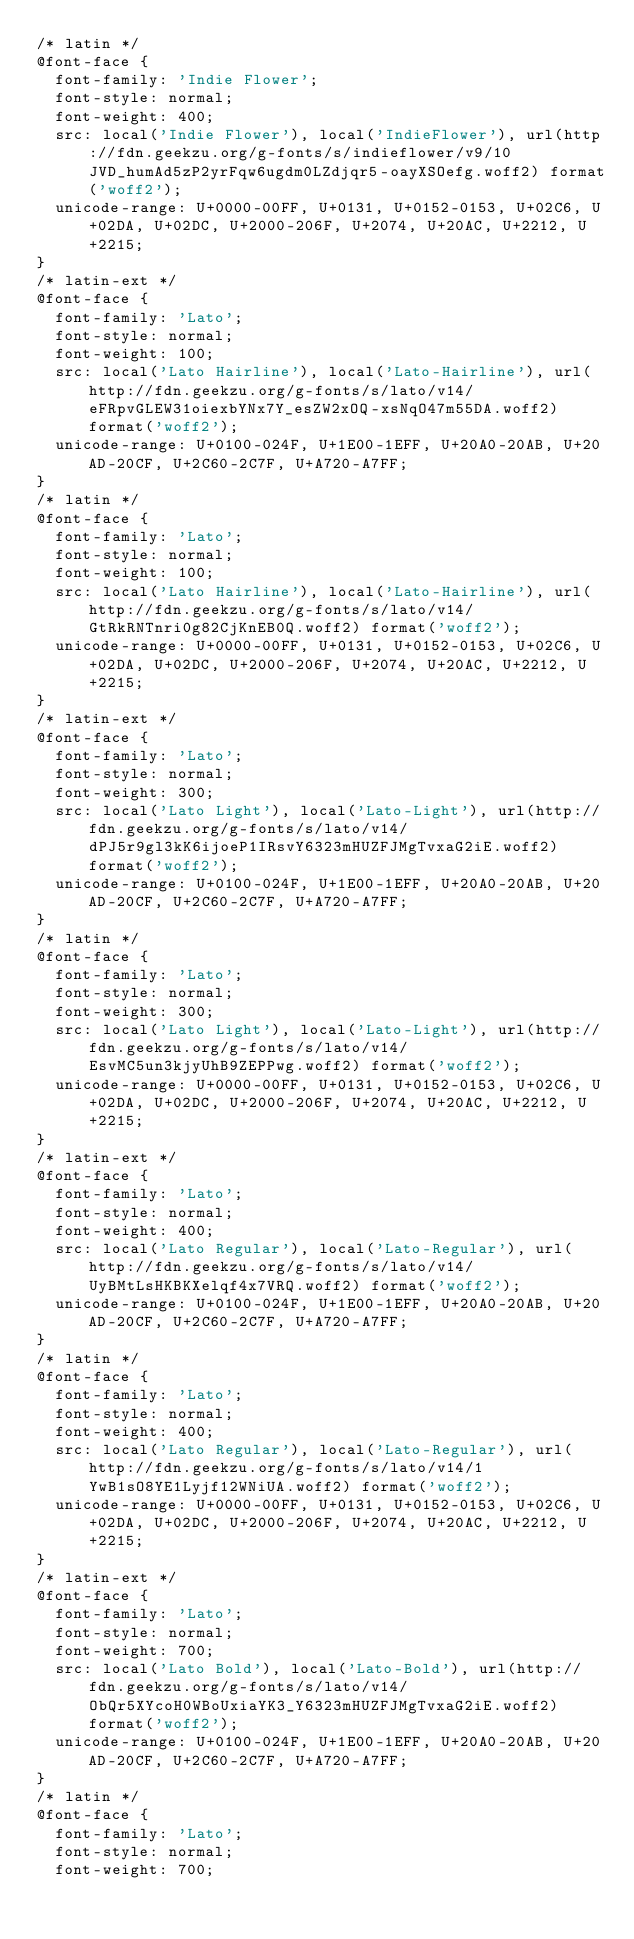Convert code to text. <code><loc_0><loc_0><loc_500><loc_500><_CSS_>/* latin */
@font-face {
  font-family: 'Indie Flower';
  font-style: normal;
  font-weight: 400;
  src: local('Indie Flower'), local('IndieFlower'), url(http://fdn.geekzu.org/g-fonts/s/indieflower/v9/10JVD_humAd5zP2yrFqw6ugdm0LZdjqr5-oayXSOefg.woff2) format('woff2');
  unicode-range: U+0000-00FF, U+0131, U+0152-0153, U+02C6, U+02DA, U+02DC, U+2000-206F, U+2074, U+20AC, U+2212, U+2215;
}
/* latin-ext */
@font-face {
  font-family: 'Lato';
  font-style: normal;
  font-weight: 100;
  src: local('Lato Hairline'), local('Lato-Hairline'), url(http://fdn.geekzu.org/g-fonts/s/lato/v14/eFRpvGLEW31oiexbYNx7Y_esZW2xOQ-xsNqO47m55DA.woff2) format('woff2');
  unicode-range: U+0100-024F, U+1E00-1EFF, U+20A0-20AB, U+20AD-20CF, U+2C60-2C7F, U+A720-A7FF;
}
/* latin */
@font-face {
  font-family: 'Lato';
  font-style: normal;
  font-weight: 100;
  src: local('Lato Hairline'), local('Lato-Hairline'), url(http://fdn.geekzu.org/g-fonts/s/lato/v14/GtRkRNTnri0g82CjKnEB0Q.woff2) format('woff2');
  unicode-range: U+0000-00FF, U+0131, U+0152-0153, U+02C6, U+02DA, U+02DC, U+2000-206F, U+2074, U+20AC, U+2212, U+2215;
}
/* latin-ext */
@font-face {
  font-family: 'Lato';
  font-style: normal;
  font-weight: 300;
  src: local('Lato Light'), local('Lato-Light'), url(http://fdn.geekzu.org/g-fonts/s/lato/v14/dPJ5r9gl3kK6ijoeP1IRsvY6323mHUZFJMgTvxaG2iE.woff2) format('woff2');
  unicode-range: U+0100-024F, U+1E00-1EFF, U+20A0-20AB, U+20AD-20CF, U+2C60-2C7F, U+A720-A7FF;
}
/* latin */
@font-face {
  font-family: 'Lato';
  font-style: normal;
  font-weight: 300;
  src: local('Lato Light'), local('Lato-Light'), url(http://fdn.geekzu.org/g-fonts/s/lato/v14/EsvMC5un3kjyUhB9ZEPPwg.woff2) format('woff2');
  unicode-range: U+0000-00FF, U+0131, U+0152-0153, U+02C6, U+02DA, U+02DC, U+2000-206F, U+2074, U+20AC, U+2212, U+2215;
}
/* latin-ext */
@font-face {
  font-family: 'Lato';
  font-style: normal;
  font-weight: 400;
  src: local('Lato Regular'), local('Lato-Regular'), url(http://fdn.geekzu.org/g-fonts/s/lato/v14/UyBMtLsHKBKXelqf4x7VRQ.woff2) format('woff2');
  unicode-range: U+0100-024F, U+1E00-1EFF, U+20A0-20AB, U+20AD-20CF, U+2C60-2C7F, U+A720-A7FF;
}
/* latin */
@font-face {
  font-family: 'Lato';
  font-style: normal;
  font-weight: 400;
  src: local('Lato Regular'), local('Lato-Regular'), url(http://fdn.geekzu.org/g-fonts/s/lato/v14/1YwB1sO8YE1Lyjf12WNiUA.woff2) format('woff2');
  unicode-range: U+0000-00FF, U+0131, U+0152-0153, U+02C6, U+02DA, U+02DC, U+2000-206F, U+2074, U+20AC, U+2212, U+2215;
}
/* latin-ext */
@font-face {
  font-family: 'Lato';
  font-style: normal;
  font-weight: 700;
  src: local('Lato Bold'), local('Lato-Bold'), url(http://fdn.geekzu.org/g-fonts/s/lato/v14/ObQr5XYcoH0WBoUxiaYK3_Y6323mHUZFJMgTvxaG2iE.woff2) format('woff2');
  unicode-range: U+0100-024F, U+1E00-1EFF, U+20A0-20AB, U+20AD-20CF, U+2C60-2C7F, U+A720-A7FF;
}
/* latin */
@font-face {
  font-family: 'Lato';
  font-style: normal;
  font-weight: 700;</code> 